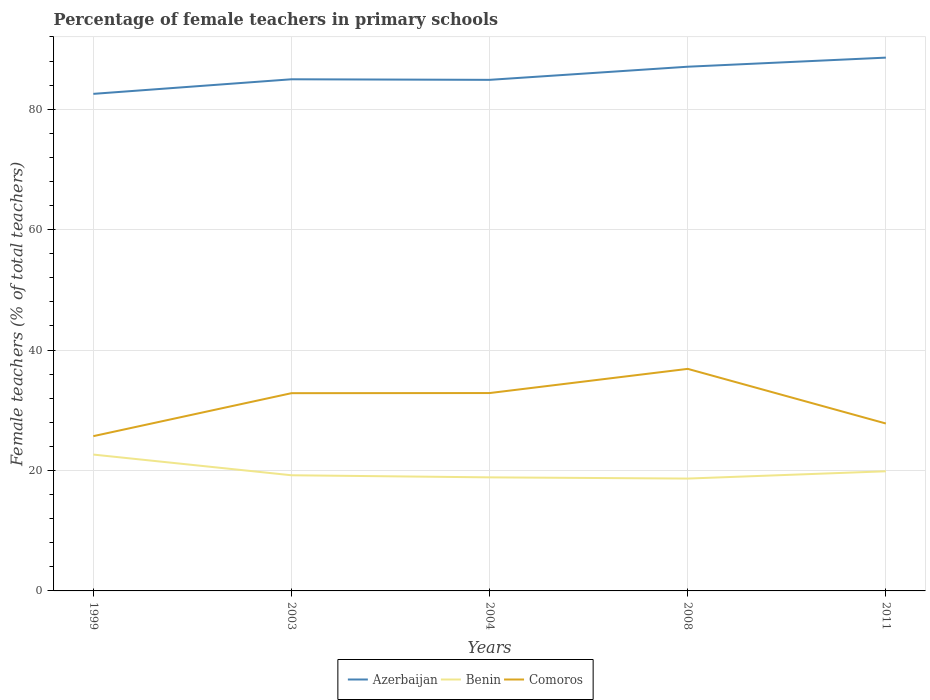How many different coloured lines are there?
Provide a succinct answer. 3. Is the number of lines equal to the number of legend labels?
Offer a terse response. Yes. Across all years, what is the maximum percentage of female teachers in Comoros?
Give a very brief answer. 25.7. In which year was the percentage of female teachers in Comoros maximum?
Offer a very short reply. 1999. What is the total percentage of female teachers in Azerbaijan in the graph?
Keep it short and to the point. -6.02. What is the difference between the highest and the second highest percentage of female teachers in Azerbaijan?
Ensure brevity in your answer.  6.02. What is the difference between the highest and the lowest percentage of female teachers in Benin?
Your answer should be compact. 2. How many years are there in the graph?
Provide a succinct answer. 5. What is the difference between two consecutive major ticks on the Y-axis?
Provide a short and direct response. 20. Are the values on the major ticks of Y-axis written in scientific E-notation?
Provide a short and direct response. No. Does the graph contain grids?
Offer a very short reply. Yes. Where does the legend appear in the graph?
Keep it short and to the point. Bottom center. How are the legend labels stacked?
Ensure brevity in your answer.  Horizontal. What is the title of the graph?
Provide a succinct answer. Percentage of female teachers in primary schools. Does "Congo (Democratic)" appear as one of the legend labels in the graph?
Make the answer very short. No. What is the label or title of the Y-axis?
Give a very brief answer. Female teachers (% of total teachers). What is the Female teachers (% of total teachers) of Azerbaijan in 1999?
Make the answer very short. 82.55. What is the Female teachers (% of total teachers) in Benin in 1999?
Offer a very short reply. 22.64. What is the Female teachers (% of total teachers) in Comoros in 1999?
Provide a short and direct response. 25.7. What is the Female teachers (% of total teachers) in Azerbaijan in 2003?
Keep it short and to the point. 84.97. What is the Female teachers (% of total teachers) of Benin in 2003?
Make the answer very short. 19.21. What is the Female teachers (% of total teachers) of Comoros in 2003?
Ensure brevity in your answer.  32.84. What is the Female teachers (% of total teachers) of Azerbaijan in 2004?
Provide a short and direct response. 84.88. What is the Female teachers (% of total teachers) in Benin in 2004?
Give a very brief answer. 18.86. What is the Female teachers (% of total teachers) in Comoros in 2004?
Make the answer very short. 32.86. What is the Female teachers (% of total teachers) of Azerbaijan in 2008?
Offer a very short reply. 87.06. What is the Female teachers (% of total teachers) of Benin in 2008?
Offer a terse response. 18.66. What is the Female teachers (% of total teachers) of Comoros in 2008?
Keep it short and to the point. 36.88. What is the Female teachers (% of total teachers) of Azerbaijan in 2011?
Offer a terse response. 88.57. What is the Female teachers (% of total teachers) of Benin in 2011?
Provide a short and direct response. 19.87. What is the Female teachers (% of total teachers) of Comoros in 2011?
Provide a succinct answer. 27.8. Across all years, what is the maximum Female teachers (% of total teachers) in Azerbaijan?
Make the answer very short. 88.57. Across all years, what is the maximum Female teachers (% of total teachers) in Benin?
Give a very brief answer. 22.64. Across all years, what is the maximum Female teachers (% of total teachers) in Comoros?
Offer a very short reply. 36.88. Across all years, what is the minimum Female teachers (% of total teachers) of Azerbaijan?
Offer a terse response. 82.55. Across all years, what is the minimum Female teachers (% of total teachers) of Benin?
Your answer should be compact. 18.66. Across all years, what is the minimum Female teachers (% of total teachers) in Comoros?
Make the answer very short. 25.7. What is the total Female teachers (% of total teachers) of Azerbaijan in the graph?
Your answer should be compact. 428.03. What is the total Female teachers (% of total teachers) of Benin in the graph?
Provide a short and direct response. 99.24. What is the total Female teachers (% of total teachers) in Comoros in the graph?
Offer a terse response. 156.09. What is the difference between the Female teachers (% of total teachers) in Azerbaijan in 1999 and that in 2003?
Your response must be concise. -2.42. What is the difference between the Female teachers (% of total teachers) in Benin in 1999 and that in 2003?
Ensure brevity in your answer.  3.44. What is the difference between the Female teachers (% of total teachers) of Comoros in 1999 and that in 2003?
Provide a short and direct response. -7.14. What is the difference between the Female teachers (% of total teachers) of Azerbaijan in 1999 and that in 2004?
Keep it short and to the point. -2.33. What is the difference between the Female teachers (% of total teachers) of Benin in 1999 and that in 2004?
Make the answer very short. 3.78. What is the difference between the Female teachers (% of total teachers) in Comoros in 1999 and that in 2004?
Offer a terse response. -7.16. What is the difference between the Female teachers (% of total teachers) of Azerbaijan in 1999 and that in 2008?
Your answer should be compact. -4.51. What is the difference between the Female teachers (% of total teachers) of Benin in 1999 and that in 2008?
Offer a very short reply. 3.98. What is the difference between the Female teachers (% of total teachers) of Comoros in 1999 and that in 2008?
Your answer should be compact. -11.18. What is the difference between the Female teachers (% of total teachers) of Azerbaijan in 1999 and that in 2011?
Make the answer very short. -6.02. What is the difference between the Female teachers (% of total teachers) of Benin in 1999 and that in 2011?
Provide a short and direct response. 2.78. What is the difference between the Female teachers (% of total teachers) in Comoros in 1999 and that in 2011?
Your response must be concise. -2.1. What is the difference between the Female teachers (% of total teachers) of Azerbaijan in 2003 and that in 2004?
Keep it short and to the point. 0.1. What is the difference between the Female teachers (% of total teachers) in Benin in 2003 and that in 2004?
Give a very brief answer. 0.35. What is the difference between the Female teachers (% of total teachers) of Comoros in 2003 and that in 2004?
Your response must be concise. -0.02. What is the difference between the Female teachers (% of total teachers) of Azerbaijan in 2003 and that in 2008?
Your response must be concise. -2.09. What is the difference between the Female teachers (% of total teachers) in Benin in 2003 and that in 2008?
Your response must be concise. 0.55. What is the difference between the Female teachers (% of total teachers) in Comoros in 2003 and that in 2008?
Make the answer very short. -4.04. What is the difference between the Female teachers (% of total teachers) of Azerbaijan in 2003 and that in 2011?
Provide a short and direct response. -3.6. What is the difference between the Female teachers (% of total teachers) of Benin in 2003 and that in 2011?
Your answer should be compact. -0.66. What is the difference between the Female teachers (% of total teachers) of Comoros in 2003 and that in 2011?
Provide a succinct answer. 5.04. What is the difference between the Female teachers (% of total teachers) of Azerbaijan in 2004 and that in 2008?
Keep it short and to the point. -2.18. What is the difference between the Female teachers (% of total teachers) of Benin in 2004 and that in 2008?
Provide a short and direct response. 0.2. What is the difference between the Female teachers (% of total teachers) in Comoros in 2004 and that in 2008?
Your answer should be compact. -4.02. What is the difference between the Female teachers (% of total teachers) of Azerbaijan in 2004 and that in 2011?
Your response must be concise. -3.69. What is the difference between the Female teachers (% of total teachers) in Benin in 2004 and that in 2011?
Your answer should be compact. -1.01. What is the difference between the Female teachers (% of total teachers) in Comoros in 2004 and that in 2011?
Your answer should be compact. 5.06. What is the difference between the Female teachers (% of total teachers) in Azerbaijan in 2008 and that in 2011?
Your response must be concise. -1.51. What is the difference between the Female teachers (% of total teachers) in Benin in 2008 and that in 2011?
Provide a succinct answer. -1.21. What is the difference between the Female teachers (% of total teachers) of Comoros in 2008 and that in 2011?
Give a very brief answer. 9.08. What is the difference between the Female teachers (% of total teachers) in Azerbaijan in 1999 and the Female teachers (% of total teachers) in Benin in 2003?
Ensure brevity in your answer.  63.34. What is the difference between the Female teachers (% of total teachers) in Azerbaijan in 1999 and the Female teachers (% of total teachers) in Comoros in 2003?
Offer a terse response. 49.71. What is the difference between the Female teachers (% of total teachers) of Benin in 1999 and the Female teachers (% of total teachers) of Comoros in 2003?
Make the answer very short. -10.2. What is the difference between the Female teachers (% of total teachers) in Azerbaijan in 1999 and the Female teachers (% of total teachers) in Benin in 2004?
Ensure brevity in your answer.  63.69. What is the difference between the Female teachers (% of total teachers) in Azerbaijan in 1999 and the Female teachers (% of total teachers) in Comoros in 2004?
Your answer should be compact. 49.69. What is the difference between the Female teachers (% of total teachers) of Benin in 1999 and the Female teachers (% of total teachers) of Comoros in 2004?
Make the answer very short. -10.22. What is the difference between the Female teachers (% of total teachers) of Azerbaijan in 1999 and the Female teachers (% of total teachers) of Benin in 2008?
Offer a very short reply. 63.89. What is the difference between the Female teachers (% of total teachers) in Azerbaijan in 1999 and the Female teachers (% of total teachers) in Comoros in 2008?
Provide a short and direct response. 45.67. What is the difference between the Female teachers (% of total teachers) of Benin in 1999 and the Female teachers (% of total teachers) of Comoros in 2008?
Give a very brief answer. -14.23. What is the difference between the Female teachers (% of total teachers) in Azerbaijan in 1999 and the Female teachers (% of total teachers) in Benin in 2011?
Your response must be concise. 62.68. What is the difference between the Female teachers (% of total teachers) in Azerbaijan in 1999 and the Female teachers (% of total teachers) in Comoros in 2011?
Offer a very short reply. 54.75. What is the difference between the Female teachers (% of total teachers) in Benin in 1999 and the Female teachers (% of total teachers) in Comoros in 2011?
Keep it short and to the point. -5.16. What is the difference between the Female teachers (% of total teachers) of Azerbaijan in 2003 and the Female teachers (% of total teachers) of Benin in 2004?
Give a very brief answer. 66.11. What is the difference between the Female teachers (% of total teachers) of Azerbaijan in 2003 and the Female teachers (% of total teachers) of Comoros in 2004?
Your answer should be very brief. 52.11. What is the difference between the Female teachers (% of total teachers) of Benin in 2003 and the Female teachers (% of total teachers) of Comoros in 2004?
Your answer should be compact. -13.65. What is the difference between the Female teachers (% of total teachers) of Azerbaijan in 2003 and the Female teachers (% of total teachers) of Benin in 2008?
Your answer should be compact. 66.31. What is the difference between the Female teachers (% of total teachers) of Azerbaijan in 2003 and the Female teachers (% of total teachers) of Comoros in 2008?
Offer a terse response. 48.09. What is the difference between the Female teachers (% of total teachers) in Benin in 2003 and the Female teachers (% of total teachers) in Comoros in 2008?
Ensure brevity in your answer.  -17.67. What is the difference between the Female teachers (% of total teachers) of Azerbaijan in 2003 and the Female teachers (% of total teachers) of Benin in 2011?
Ensure brevity in your answer.  65.1. What is the difference between the Female teachers (% of total teachers) in Azerbaijan in 2003 and the Female teachers (% of total teachers) in Comoros in 2011?
Ensure brevity in your answer.  57.17. What is the difference between the Female teachers (% of total teachers) of Benin in 2003 and the Female teachers (% of total teachers) of Comoros in 2011?
Provide a succinct answer. -8.6. What is the difference between the Female teachers (% of total teachers) of Azerbaijan in 2004 and the Female teachers (% of total teachers) of Benin in 2008?
Make the answer very short. 66.22. What is the difference between the Female teachers (% of total teachers) of Azerbaijan in 2004 and the Female teachers (% of total teachers) of Comoros in 2008?
Your answer should be very brief. 48. What is the difference between the Female teachers (% of total teachers) of Benin in 2004 and the Female teachers (% of total teachers) of Comoros in 2008?
Your response must be concise. -18.02. What is the difference between the Female teachers (% of total teachers) in Azerbaijan in 2004 and the Female teachers (% of total teachers) in Benin in 2011?
Give a very brief answer. 65.01. What is the difference between the Female teachers (% of total teachers) of Azerbaijan in 2004 and the Female teachers (% of total teachers) of Comoros in 2011?
Give a very brief answer. 57.07. What is the difference between the Female teachers (% of total teachers) in Benin in 2004 and the Female teachers (% of total teachers) in Comoros in 2011?
Your answer should be very brief. -8.94. What is the difference between the Female teachers (% of total teachers) of Azerbaijan in 2008 and the Female teachers (% of total teachers) of Benin in 2011?
Your answer should be compact. 67.19. What is the difference between the Female teachers (% of total teachers) of Azerbaijan in 2008 and the Female teachers (% of total teachers) of Comoros in 2011?
Keep it short and to the point. 59.26. What is the difference between the Female teachers (% of total teachers) in Benin in 2008 and the Female teachers (% of total teachers) in Comoros in 2011?
Your answer should be very brief. -9.14. What is the average Female teachers (% of total teachers) of Azerbaijan per year?
Offer a terse response. 85.61. What is the average Female teachers (% of total teachers) in Benin per year?
Ensure brevity in your answer.  19.85. What is the average Female teachers (% of total teachers) in Comoros per year?
Offer a very short reply. 31.22. In the year 1999, what is the difference between the Female teachers (% of total teachers) in Azerbaijan and Female teachers (% of total teachers) in Benin?
Provide a succinct answer. 59.91. In the year 1999, what is the difference between the Female teachers (% of total teachers) in Azerbaijan and Female teachers (% of total teachers) in Comoros?
Make the answer very short. 56.85. In the year 1999, what is the difference between the Female teachers (% of total teachers) of Benin and Female teachers (% of total teachers) of Comoros?
Your answer should be compact. -3.06. In the year 2003, what is the difference between the Female teachers (% of total teachers) of Azerbaijan and Female teachers (% of total teachers) of Benin?
Provide a succinct answer. 65.77. In the year 2003, what is the difference between the Female teachers (% of total teachers) in Azerbaijan and Female teachers (% of total teachers) in Comoros?
Offer a terse response. 52.13. In the year 2003, what is the difference between the Female teachers (% of total teachers) of Benin and Female teachers (% of total teachers) of Comoros?
Keep it short and to the point. -13.63. In the year 2004, what is the difference between the Female teachers (% of total teachers) of Azerbaijan and Female teachers (% of total teachers) of Benin?
Your answer should be very brief. 66.02. In the year 2004, what is the difference between the Female teachers (% of total teachers) in Azerbaijan and Female teachers (% of total teachers) in Comoros?
Provide a short and direct response. 52.02. In the year 2004, what is the difference between the Female teachers (% of total teachers) in Benin and Female teachers (% of total teachers) in Comoros?
Your answer should be compact. -14. In the year 2008, what is the difference between the Female teachers (% of total teachers) in Azerbaijan and Female teachers (% of total teachers) in Benin?
Make the answer very short. 68.4. In the year 2008, what is the difference between the Female teachers (% of total teachers) in Azerbaijan and Female teachers (% of total teachers) in Comoros?
Keep it short and to the point. 50.18. In the year 2008, what is the difference between the Female teachers (% of total teachers) in Benin and Female teachers (% of total teachers) in Comoros?
Keep it short and to the point. -18.22. In the year 2011, what is the difference between the Female teachers (% of total teachers) in Azerbaijan and Female teachers (% of total teachers) in Benin?
Make the answer very short. 68.7. In the year 2011, what is the difference between the Female teachers (% of total teachers) of Azerbaijan and Female teachers (% of total teachers) of Comoros?
Offer a very short reply. 60.77. In the year 2011, what is the difference between the Female teachers (% of total teachers) of Benin and Female teachers (% of total teachers) of Comoros?
Ensure brevity in your answer.  -7.93. What is the ratio of the Female teachers (% of total teachers) of Azerbaijan in 1999 to that in 2003?
Make the answer very short. 0.97. What is the ratio of the Female teachers (% of total teachers) in Benin in 1999 to that in 2003?
Offer a very short reply. 1.18. What is the ratio of the Female teachers (% of total teachers) of Comoros in 1999 to that in 2003?
Offer a terse response. 0.78. What is the ratio of the Female teachers (% of total teachers) of Azerbaijan in 1999 to that in 2004?
Provide a succinct answer. 0.97. What is the ratio of the Female teachers (% of total teachers) of Benin in 1999 to that in 2004?
Provide a short and direct response. 1.2. What is the ratio of the Female teachers (% of total teachers) in Comoros in 1999 to that in 2004?
Ensure brevity in your answer.  0.78. What is the ratio of the Female teachers (% of total teachers) in Azerbaijan in 1999 to that in 2008?
Keep it short and to the point. 0.95. What is the ratio of the Female teachers (% of total teachers) in Benin in 1999 to that in 2008?
Your answer should be compact. 1.21. What is the ratio of the Female teachers (% of total teachers) of Comoros in 1999 to that in 2008?
Provide a succinct answer. 0.7. What is the ratio of the Female teachers (% of total teachers) of Azerbaijan in 1999 to that in 2011?
Give a very brief answer. 0.93. What is the ratio of the Female teachers (% of total teachers) of Benin in 1999 to that in 2011?
Make the answer very short. 1.14. What is the ratio of the Female teachers (% of total teachers) of Comoros in 1999 to that in 2011?
Give a very brief answer. 0.92. What is the ratio of the Female teachers (% of total teachers) of Benin in 2003 to that in 2004?
Provide a succinct answer. 1.02. What is the ratio of the Female teachers (% of total teachers) of Comoros in 2003 to that in 2004?
Give a very brief answer. 1. What is the ratio of the Female teachers (% of total teachers) in Benin in 2003 to that in 2008?
Your answer should be compact. 1.03. What is the ratio of the Female teachers (% of total teachers) in Comoros in 2003 to that in 2008?
Provide a short and direct response. 0.89. What is the ratio of the Female teachers (% of total teachers) of Azerbaijan in 2003 to that in 2011?
Your response must be concise. 0.96. What is the ratio of the Female teachers (% of total teachers) in Benin in 2003 to that in 2011?
Your response must be concise. 0.97. What is the ratio of the Female teachers (% of total teachers) in Comoros in 2003 to that in 2011?
Offer a very short reply. 1.18. What is the ratio of the Female teachers (% of total teachers) of Azerbaijan in 2004 to that in 2008?
Keep it short and to the point. 0.97. What is the ratio of the Female teachers (% of total teachers) of Benin in 2004 to that in 2008?
Your answer should be compact. 1.01. What is the ratio of the Female teachers (% of total teachers) of Comoros in 2004 to that in 2008?
Make the answer very short. 0.89. What is the ratio of the Female teachers (% of total teachers) in Benin in 2004 to that in 2011?
Your answer should be compact. 0.95. What is the ratio of the Female teachers (% of total teachers) of Comoros in 2004 to that in 2011?
Provide a succinct answer. 1.18. What is the ratio of the Female teachers (% of total teachers) in Benin in 2008 to that in 2011?
Your response must be concise. 0.94. What is the ratio of the Female teachers (% of total teachers) in Comoros in 2008 to that in 2011?
Keep it short and to the point. 1.33. What is the difference between the highest and the second highest Female teachers (% of total teachers) of Azerbaijan?
Offer a terse response. 1.51. What is the difference between the highest and the second highest Female teachers (% of total teachers) of Benin?
Provide a short and direct response. 2.78. What is the difference between the highest and the second highest Female teachers (% of total teachers) of Comoros?
Provide a short and direct response. 4.02. What is the difference between the highest and the lowest Female teachers (% of total teachers) of Azerbaijan?
Provide a succinct answer. 6.02. What is the difference between the highest and the lowest Female teachers (% of total teachers) in Benin?
Your answer should be very brief. 3.98. What is the difference between the highest and the lowest Female teachers (% of total teachers) of Comoros?
Offer a terse response. 11.18. 